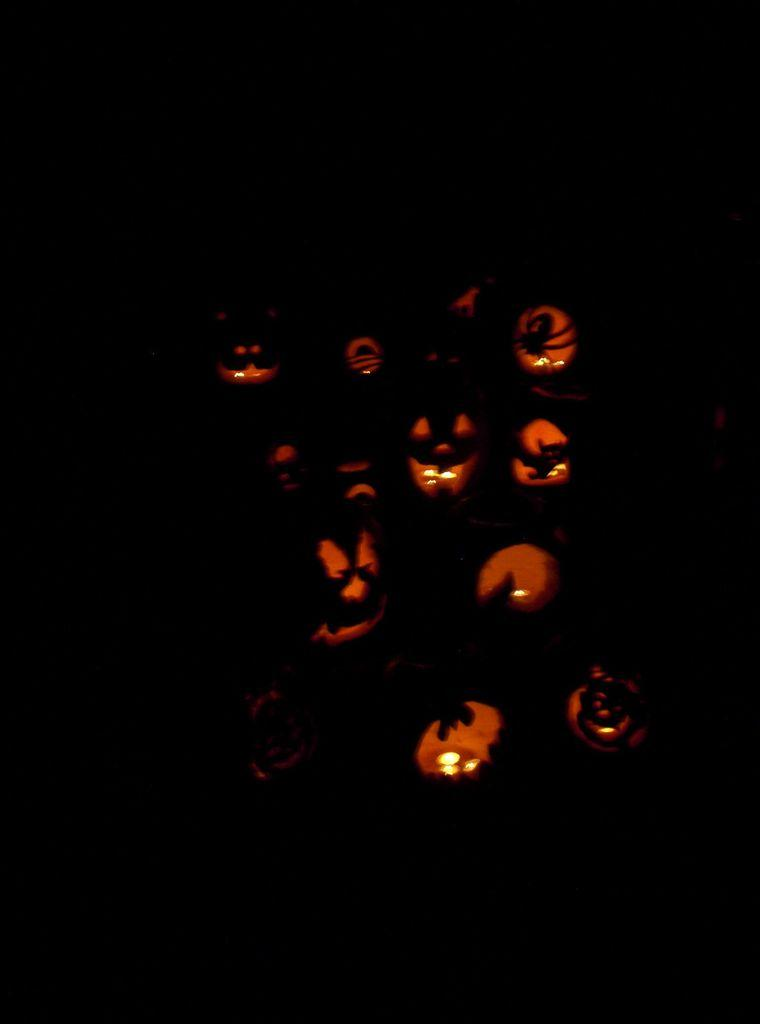What type of decorations are featured in the image? There are Halloween pumpkins in the image. What holiday are the decorations associated with? The decorations are associated with Halloween. How are the pumpkins typically used during this holiday? The pumpkins are typically carved with faces or designs. What type of authority figure can be seen in the image? There is no authority figure present in the image; it features Halloween pumpkins. What type of jam is being used to decorate the pumpkins in the image? There is no jam present in the image; it features Halloween pumpkins. 